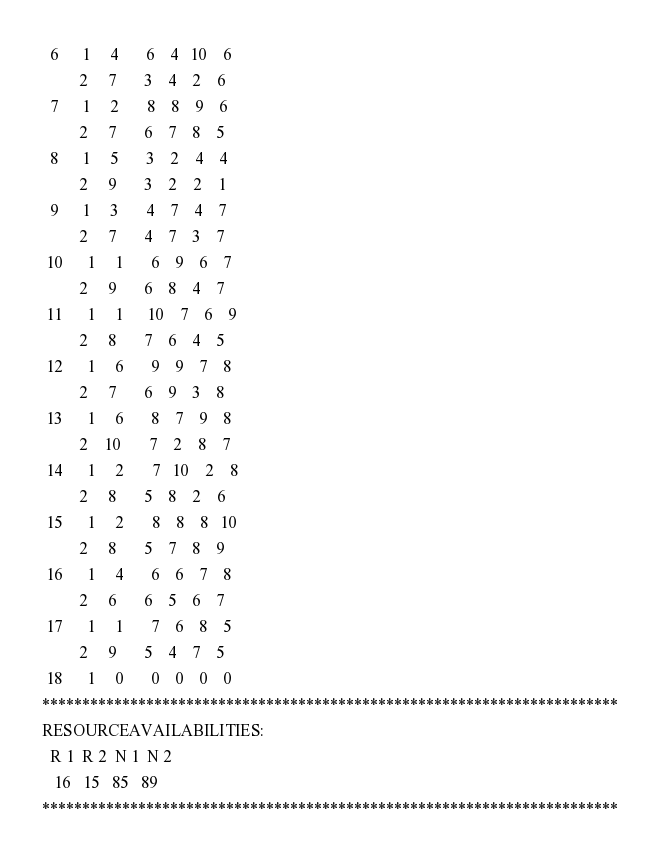Convert code to text. <code><loc_0><loc_0><loc_500><loc_500><_ObjectiveC_>  6      1     4       6    4   10    6
         2     7       3    4    2    6
  7      1     2       8    8    9    6
         2     7       6    7    8    5
  8      1     5       3    2    4    4
         2     9       3    2    2    1
  9      1     3       4    7    4    7
         2     7       4    7    3    7
 10      1     1       6    9    6    7
         2     9       6    8    4    7
 11      1     1      10    7    6    9
         2     8       7    6    4    5
 12      1     6       9    9    7    8
         2     7       6    9    3    8
 13      1     6       8    7    9    8
         2    10       7    2    8    7
 14      1     2       7   10    2    8
         2     8       5    8    2    6
 15      1     2       8    8    8   10
         2     8       5    7    8    9
 16      1     4       6    6    7    8
         2     6       6    5    6    7
 17      1     1       7    6    8    5
         2     9       5    4    7    5
 18      1     0       0    0    0    0
************************************************************************
RESOURCEAVAILABILITIES:
  R 1  R 2  N 1  N 2
   16   15   85   89
************************************************************************
</code> 